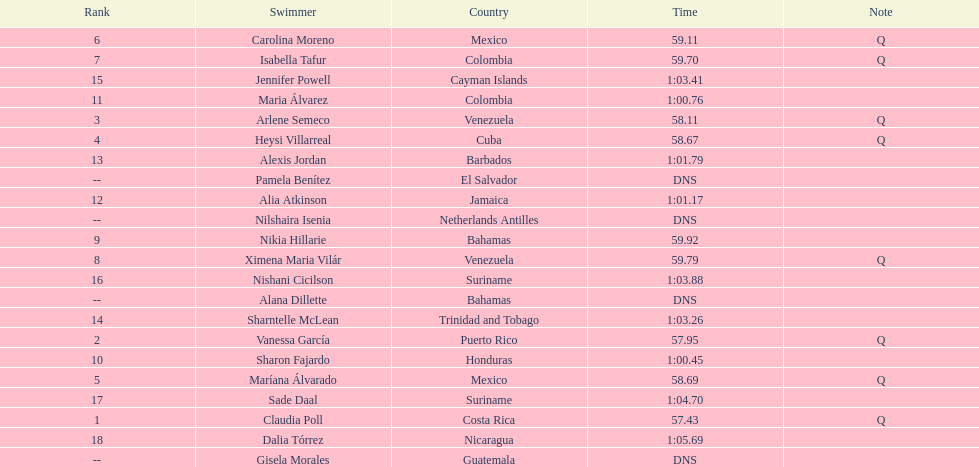How many competitors from venezuela qualified for the final? 2. I'm looking to parse the entire table for insights. Could you assist me with that? {'header': ['Rank', 'Swimmer', 'Country', 'Time', 'Note'], 'rows': [['6', 'Carolina Moreno', 'Mexico', '59.11', 'Q'], ['7', 'Isabella Tafur', 'Colombia', '59.70', 'Q'], ['15', 'Jennifer Powell', 'Cayman Islands', '1:03.41', ''], ['11', 'Maria Álvarez', 'Colombia', '1:00.76', ''], ['3', 'Arlene Semeco', 'Venezuela', '58.11', 'Q'], ['4', 'Heysi Villarreal', 'Cuba', '58.67', 'Q'], ['13', 'Alexis Jordan', 'Barbados', '1:01.79', ''], ['--', 'Pamela Benítez', 'El Salvador', 'DNS', ''], ['12', 'Alia Atkinson', 'Jamaica', '1:01.17', ''], ['--', 'Nilshaira Isenia', 'Netherlands Antilles', 'DNS', ''], ['9', 'Nikia Hillarie', 'Bahamas', '59.92', ''], ['8', 'Ximena Maria Vilár', 'Venezuela', '59.79', 'Q'], ['16', 'Nishani Cicilson', 'Suriname', '1:03.88', ''], ['--', 'Alana Dillette', 'Bahamas', 'DNS', ''], ['14', 'Sharntelle McLean', 'Trinidad and Tobago', '1:03.26', ''], ['2', 'Vanessa García', 'Puerto Rico', '57.95', 'Q'], ['10', 'Sharon Fajardo', 'Honduras', '1:00.45', ''], ['5', 'Maríana Álvarado', 'Mexico', '58.69', 'Q'], ['17', 'Sade Daal', 'Suriname', '1:04.70', ''], ['1', 'Claudia Poll', 'Costa Rica', '57.43', 'Q'], ['18', 'Dalia Tórrez', 'Nicaragua', '1:05.69', ''], ['--', 'Gisela Morales', 'Guatemala', 'DNS', '']]} 